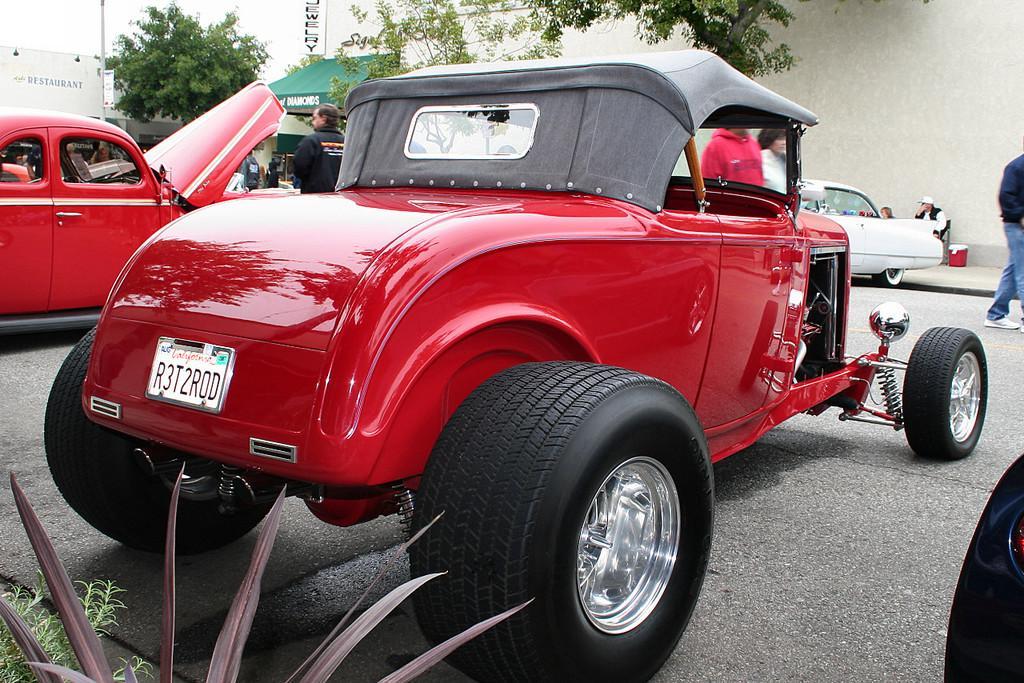How would you summarize this image in a sentence or two? In this image we can see few vehicles and there are some people and we can see some trees and plants. There are few boards with the text in the background. 